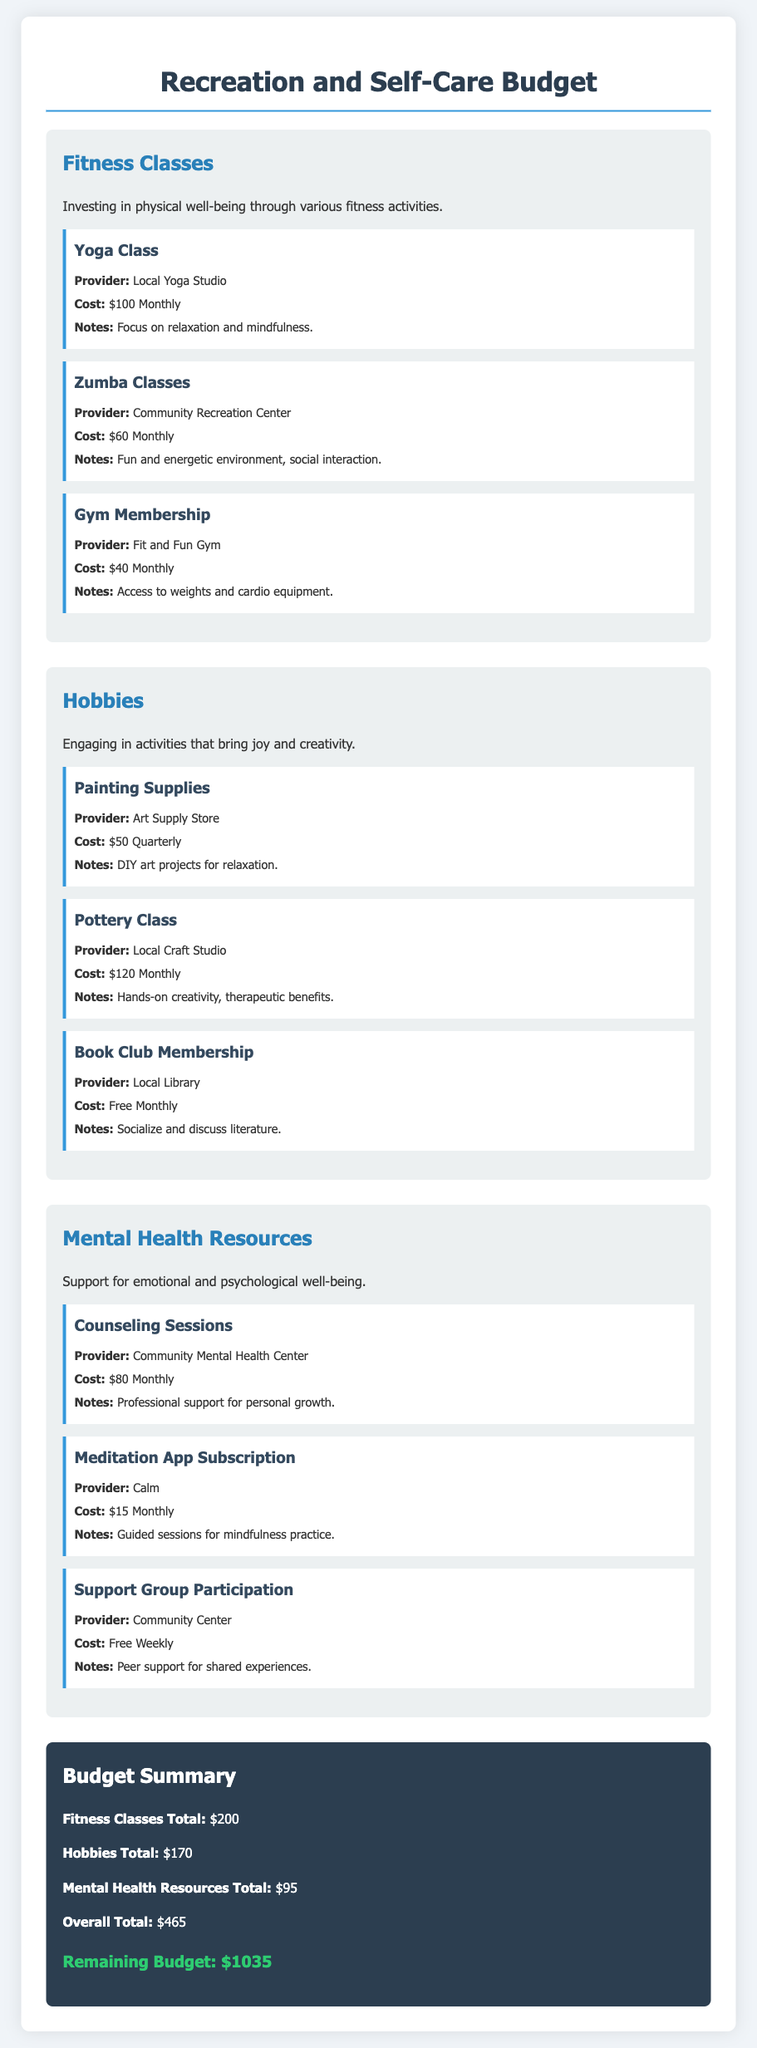What is the total cost of Yoga Class? The cost of the Yoga Class is listed as $100 Monthly in the document.
Answer: $100 Monthly How much is the Pottery Class? The Pottery Class is priced at $120 Monthly according to the activities outlined.
Answer: $120 Monthly What is the remaining budget? The document states that the remaining budget is $1035 after summarizing the expenditures.
Answer: $1035 Which fitness class costs the least? The Gym Membership is the least expensive fitness class, costing $40 Monthly.
Answer: $40 Monthly What is the total for Mental Health Resources? The total cost for Mental Health Resources, when summed from the activities, is $95.
Answer: $95 How often do you pay for the Support Group Participation? The Support Group Participation is free weekly, as mentioned in the document.
Answer: Free Weekly What is the total amount spent on Hobbies? The total amount spent on Hobbies is $170, as detailed in the budget summary.
Answer: $170 Which meditation app is mentioned? The meditation app referenced in the document is Calm.
Answer: Calm What is the provider of the Counseling Sessions? The provider for the Counseling Sessions is Community Mental Health Center listed in the activities.
Answer: Community Mental Health Center 